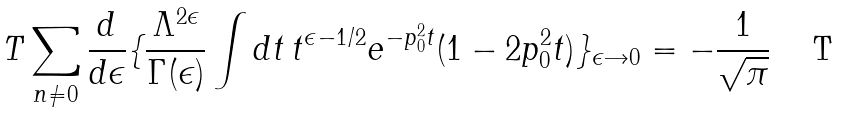Convert formula to latex. <formula><loc_0><loc_0><loc_500><loc_500>T \sum _ { n \ne 0 } \frac { d } { d \epsilon } \{ \frac { \Lambda ^ { 2 \epsilon } } { \Gamma ( \epsilon ) } \int d t \, t ^ { \epsilon - 1 / 2 } e ^ { - p _ { 0 } ^ { 2 } t } ( 1 - 2 p _ { 0 } ^ { 2 } t ) \} _ { \epsilon \rightarrow 0 } = - \frac { 1 } { \sqrt { \pi } }</formula> 